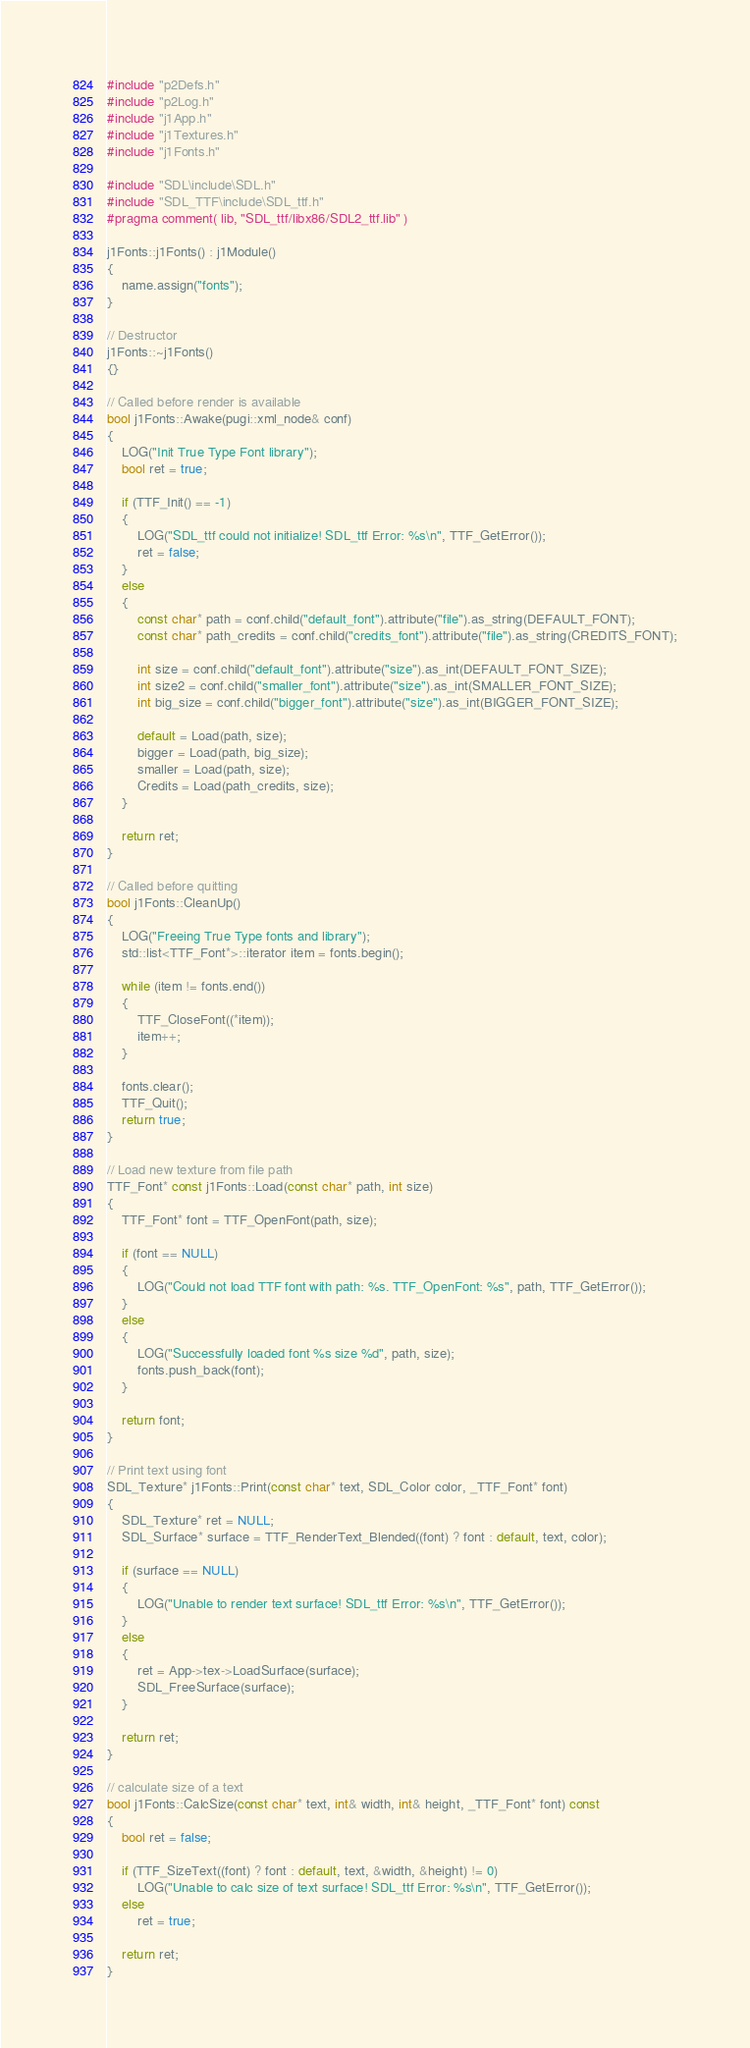Convert code to text. <code><loc_0><loc_0><loc_500><loc_500><_C++_>#include "p2Defs.h"
#include "p2Log.h"
#include "j1App.h"
#include "j1Textures.h"
#include "j1Fonts.h"

#include "SDL\include\SDL.h"
#include "SDL_TTF\include\SDL_ttf.h"
#pragma comment( lib, "SDL_ttf/libx86/SDL2_ttf.lib" )

j1Fonts::j1Fonts() : j1Module()
{
	name.assign("fonts");
}

// Destructor
j1Fonts::~j1Fonts()
{}

// Called before render is available
bool j1Fonts::Awake(pugi::xml_node& conf)
{
	LOG("Init True Type Font library");
	bool ret = true;

	if (TTF_Init() == -1)
	{
		LOG("SDL_ttf could not initialize! SDL_ttf Error: %s\n", TTF_GetError());
		ret = false;
	}
	else
	{
		const char* path = conf.child("default_font").attribute("file").as_string(DEFAULT_FONT);
		const char* path_credits = conf.child("credits_font").attribute("file").as_string(CREDITS_FONT);

		int size = conf.child("default_font").attribute("size").as_int(DEFAULT_FONT_SIZE);
		int size2 = conf.child("smaller_font").attribute("size").as_int(SMALLER_FONT_SIZE);
		int big_size = conf.child("bigger_font").attribute("size").as_int(BIGGER_FONT_SIZE);

		default = Load(path, size);
		bigger = Load(path, big_size);
		smaller = Load(path, size);
		Credits = Load(path_credits, size);
	}

	return ret;
}

// Called before quitting
bool j1Fonts::CleanUp()
{
	LOG("Freeing True Type fonts and library");
	std::list<TTF_Font*>::iterator item = fonts.begin();

	while (item != fonts.end())
	{
		TTF_CloseFont((*item));
		item++;
	}

	fonts.clear();
	TTF_Quit();
	return true;
}

// Load new texture from file path
TTF_Font* const j1Fonts::Load(const char* path, int size)
{
	TTF_Font* font = TTF_OpenFont(path, size);

	if (font == NULL)
	{
		LOG("Could not load TTF font with path: %s. TTF_OpenFont: %s", path, TTF_GetError());
	}
	else
	{
		LOG("Successfully loaded font %s size %d", path, size);
		fonts.push_back(font);
	}

	return font;
}

// Print text using font
SDL_Texture* j1Fonts::Print(const char* text, SDL_Color color, _TTF_Font* font)
{
	SDL_Texture* ret = NULL;
	SDL_Surface* surface = TTF_RenderText_Blended((font) ? font : default, text, color);

	if (surface == NULL)
	{
		LOG("Unable to render text surface! SDL_ttf Error: %s\n", TTF_GetError());
	}
	else
	{
		ret = App->tex->LoadSurface(surface);
		SDL_FreeSurface(surface);
	}

	return ret;
}

// calculate size of a text
bool j1Fonts::CalcSize(const char* text, int& width, int& height, _TTF_Font* font) const
{
	bool ret = false;

	if (TTF_SizeText((font) ? font : default, text, &width, &height) != 0)
		LOG("Unable to calc size of text surface! SDL_ttf Error: %s\n", TTF_GetError());
	else
		ret = true;

	return ret;
}</code> 